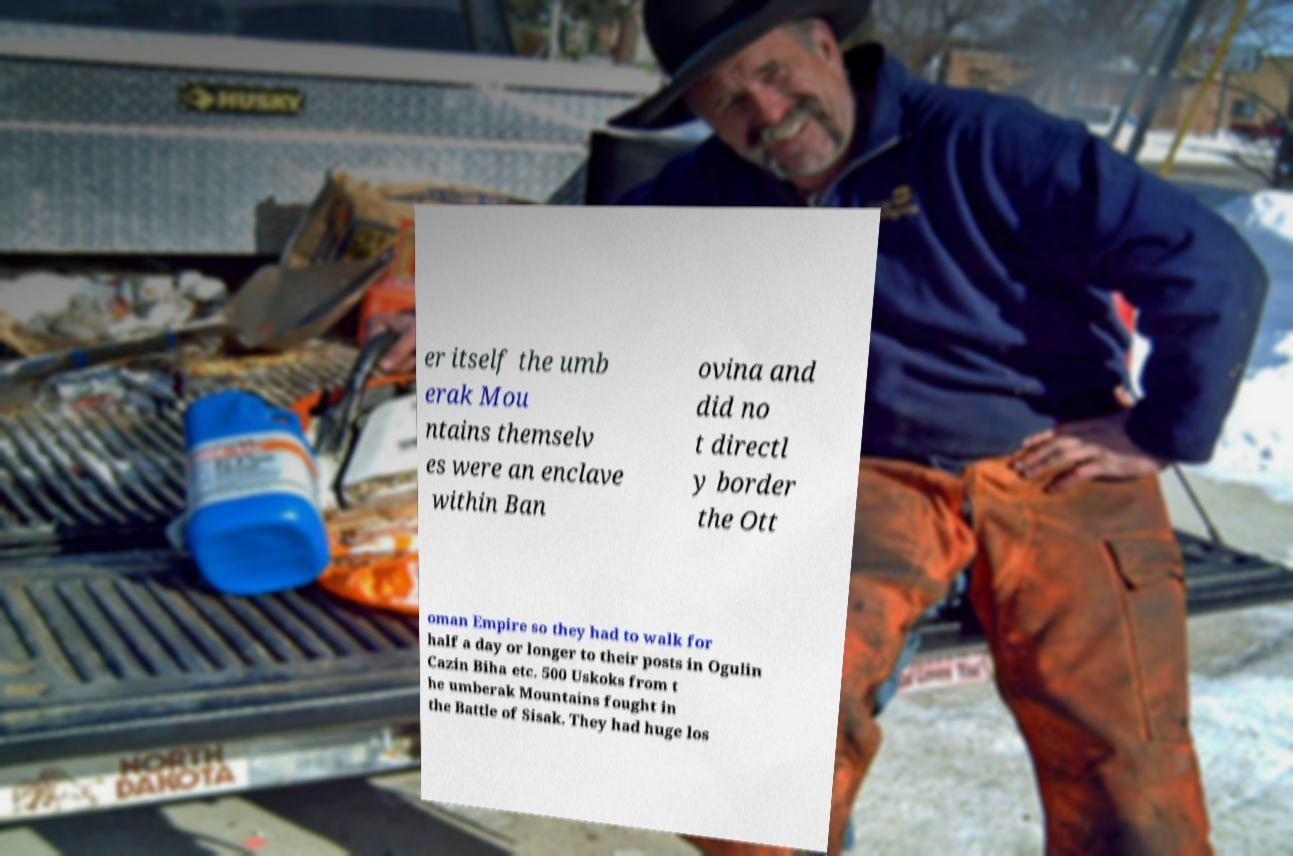There's text embedded in this image that I need extracted. Can you transcribe it verbatim? er itself the umb erak Mou ntains themselv es were an enclave within Ban ovina and did no t directl y border the Ott oman Empire so they had to walk for half a day or longer to their posts in Ogulin Cazin Biha etc. 500 Uskoks from t he umberak Mountains fought in the Battle of Sisak. They had huge los 